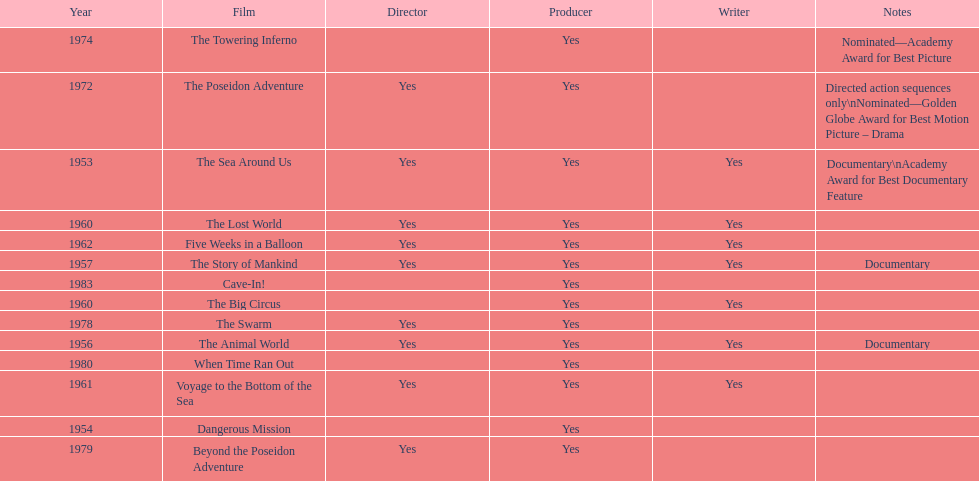How many films did irwin allen direct, produce and write? 6. 